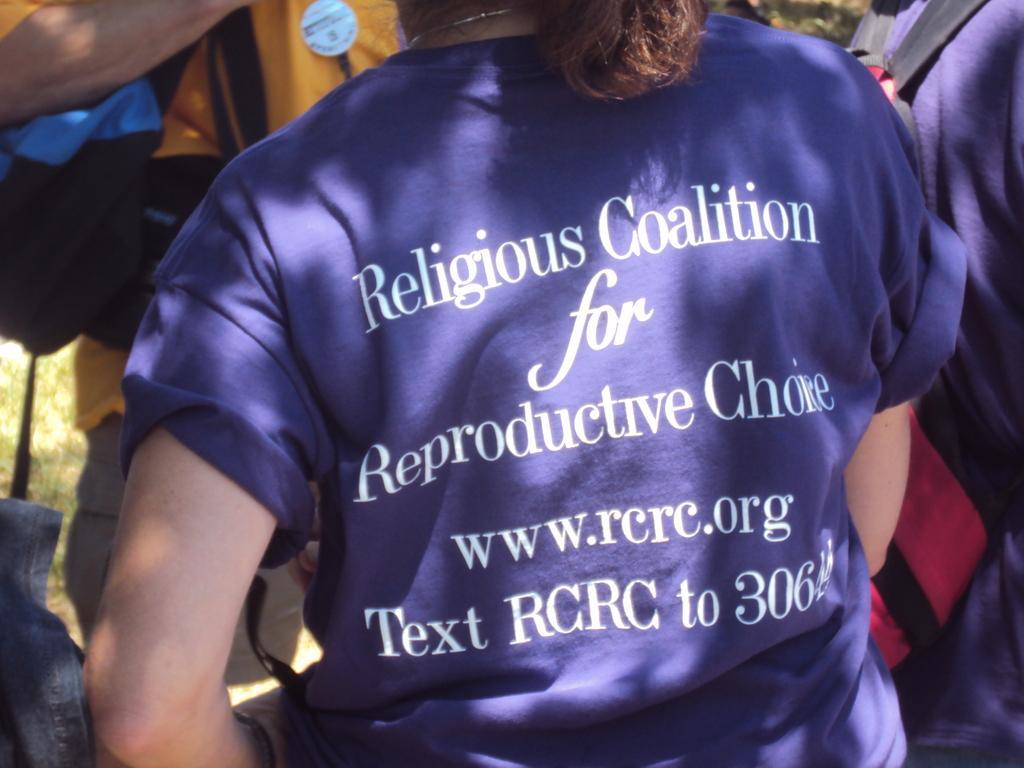Please provide a concise description of this image. In this image there is one women standing in the middle of this image is wearing a blue color t shirt and there is some text written on to this t shirt. There are some persons standing in the background. 